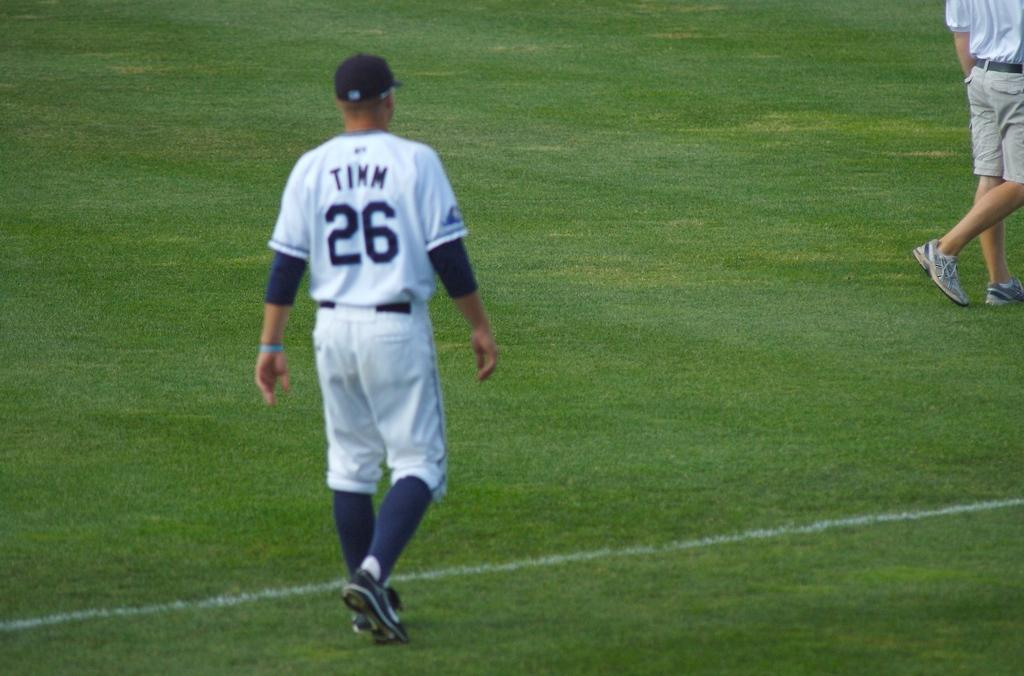<image>
Render a clear and concise summary of the photo. Baseball player wearing number 26 walking on the field. 